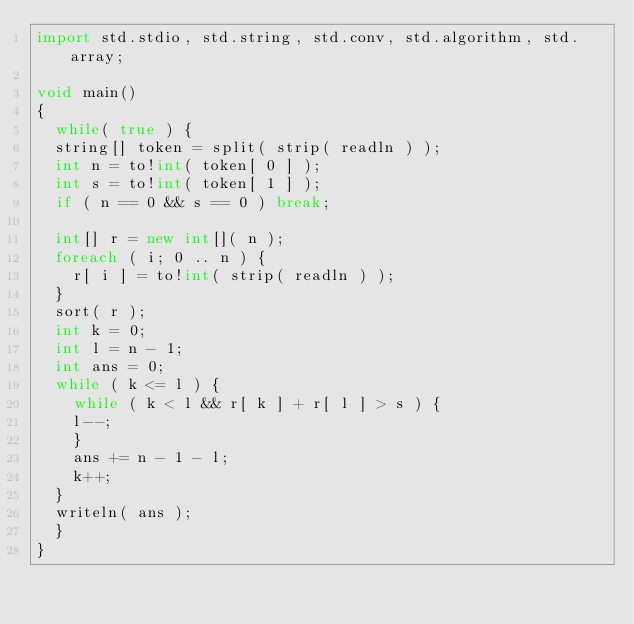Convert code to text. <code><loc_0><loc_0><loc_500><loc_500><_D_>import std.stdio, std.string, std.conv, std.algorithm, std.array;

void main()
{
  while( true ) {
	string[] token = split( strip( readln ) );
	int n = to!int( token[ 0 ] );
	int s = to!int( token[ 1 ] );
	if ( n == 0 && s == 0 ) break;

	int[] r = new int[]( n );
	foreach ( i; 0 .. n ) {
	  r[ i ] = to!int( strip( readln ) );
	}
	sort( r );
	int k = 0;
	int l = n - 1;
	int ans = 0;
	while ( k <= l ) {
	  while ( k < l && r[ k ] + r[ l ] > s ) {
		l--;
	  }
	  ans += n - 1 - l;
	  k++;
	}
	writeln( ans );
  }
}</code> 